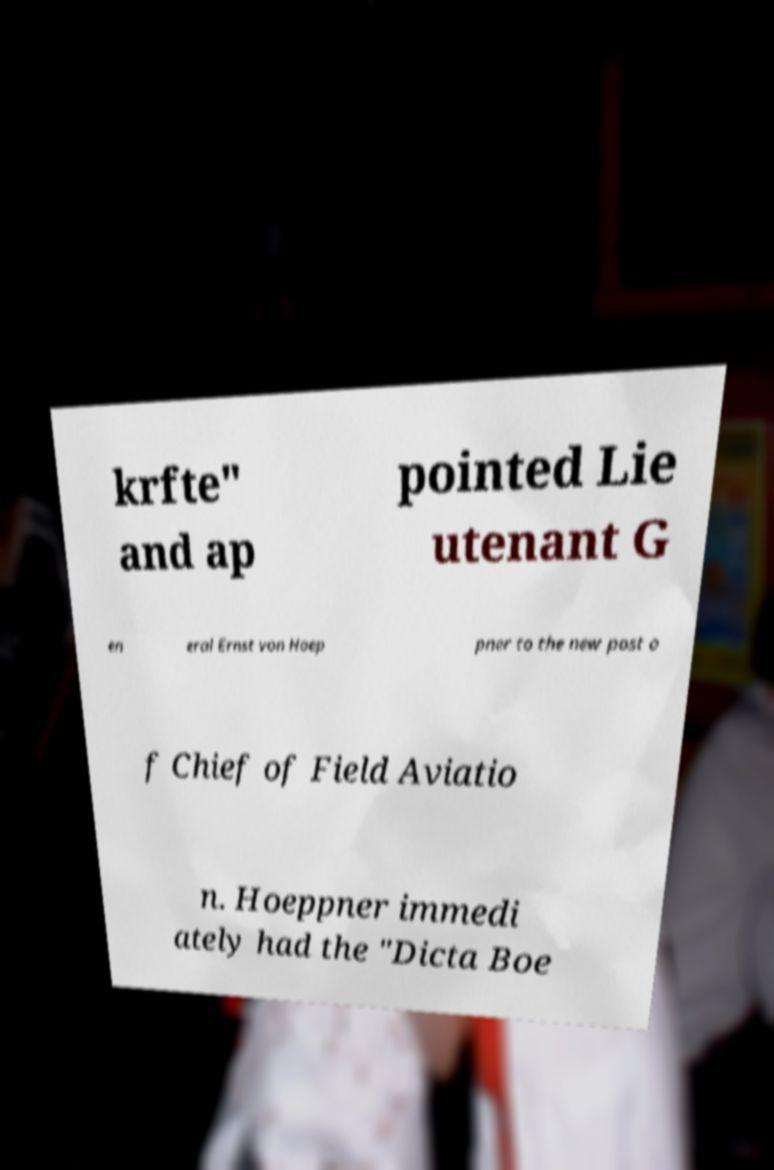Please read and relay the text visible in this image. What does it say? krfte" and ap pointed Lie utenant G en eral Ernst von Hoep pner to the new post o f Chief of Field Aviatio n. Hoeppner immedi ately had the "Dicta Boe 